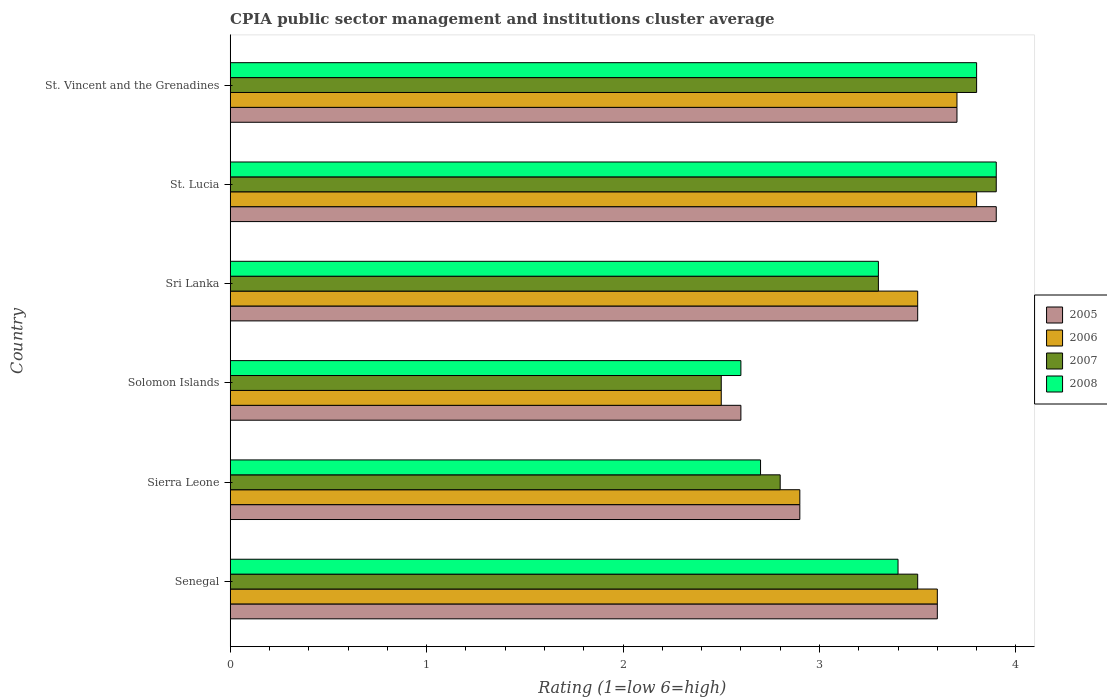How many different coloured bars are there?
Make the answer very short. 4. Are the number of bars on each tick of the Y-axis equal?
Give a very brief answer. Yes. How many bars are there on the 6th tick from the top?
Your response must be concise. 4. How many bars are there on the 2nd tick from the bottom?
Your answer should be very brief. 4. What is the label of the 2nd group of bars from the top?
Give a very brief answer. St. Lucia. Across all countries, what is the maximum CPIA rating in 2006?
Your answer should be very brief. 3.8. Across all countries, what is the minimum CPIA rating in 2005?
Provide a short and direct response. 2.6. In which country was the CPIA rating in 2005 maximum?
Your answer should be very brief. St. Lucia. In which country was the CPIA rating in 2006 minimum?
Your response must be concise. Solomon Islands. What is the total CPIA rating in 2007 in the graph?
Your answer should be compact. 19.8. What is the difference between the CPIA rating in 2006 in Senegal and that in St. Vincent and the Grenadines?
Offer a terse response. -0.1. What is the difference between the CPIA rating in 2006 in St. Lucia and the CPIA rating in 2008 in St. Vincent and the Grenadines?
Offer a very short reply. 0. What is the average CPIA rating in 2007 per country?
Provide a succinct answer. 3.3. What is the difference between the CPIA rating in 2008 and CPIA rating in 2006 in Solomon Islands?
Offer a very short reply. 0.1. What is the ratio of the CPIA rating in 2006 in Sri Lanka to that in St. Vincent and the Grenadines?
Provide a succinct answer. 0.95. Is the difference between the CPIA rating in 2008 in St. Lucia and St. Vincent and the Grenadines greater than the difference between the CPIA rating in 2006 in St. Lucia and St. Vincent and the Grenadines?
Give a very brief answer. Yes. What is the difference between the highest and the second highest CPIA rating in 2006?
Your response must be concise. 0.1. Is the sum of the CPIA rating in 2005 in Senegal and Solomon Islands greater than the maximum CPIA rating in 2008 across all countries?
Provide a short and direct response. Yes. What does the 1st bar from the top in Senegal represents?
Your answer should be compact. 2008. What does the 3rd bar from the bottom in Sierra Leone represents?
Keep it short and to the point. 2007. Are all the bars in the graph horizontal?
Offer a very short reply. Yes. How many countries are there in the graph?
Your response must be concise. 6. Are the values on the major ticks of X-axis written in scientific E-notation?
Your answer should be very brief. No. How many legend labels are there?
Your answer should be compact. 4. What is the title of the graph?
Offer a terse response. CPIA public sector management and institutions cluster average. What is the label or title of the X-axis?
Ensure brevity in your answer.  Rating (1=low 6=high). What is the label or title of the Y-axis?
Give a very brief answer. Country. What is the Rating (1=low 6=high) in 2005 in Senegal?
Keep it short and to the point. 3.6. What is the Rating (1=low 6=high) in 2008 in Senegal?
Your answer should be very brief. 3.4. What is the Rating (1=low 6=high) in 2005 in Sierra Leone?
Ensure brevity in your answer.  2.9. What is the Rating (1=low 6=high) in 2006 in Sierra Leone?
Give a very brief answer. 2.9. What is the Rating (1=low 6=high) of 2008 in Sierra Leone?
Your response must be concise. 2.7. What is the Rating (1=low 6=high) in 2008 in Solomon Islands?
Your answer should be very brief. 2.6. What is the Rating (1=low 6=high) in 2006 in Sri Lanka?
Ensure brevity in your answer.  3.5. What is the Rating (1=low 6=high) in 2007 in Sri Lanka?
Provide a short and direct response. 3.3. What is the Rating (1=low 6=high) of 2008 in Sri Lanka?
Your response must be concise. 3.3. What is the Rating (1=low 6=high) of 2005 in St. Lucia?
Give a very brief answer. 3.9. What is the Rating (1=low 6=high) in 2006 in St. Lucia?
Your answer should be very brief. 3.8. What is the Rating (1=low 6=high) of 2007 in St. Lucia?
Your response must be concise. 3.9. What is the Rating (1=low 6=high) of 2005 in St. Vincent and the Grenadines?
Provide a short and direct response. 3.7. What is the Rating (1=low 6=high) of 2007 in St. Vincent and the Grenadines?
Your answer should be very brief. 3.8. What is the Rating (1=low 6=high) of 2008 in St. Vincent and the Grenadines?
Your answer should be very brief. 3.8. Across all countries, what is the maximum Rating (1=low 6=high) of 2008?
Give a very brief answer. 3.9. Across all countries, what is the minimum Rating (1=low 6=high) in 2008?
Keep it short and to the point. 2.6. What is the total Rating (1=low 6=high) in 2005 in the graph?
Your answer should be compact. 20.2. What is the total Rating (1=low 6=high) in 2006 in the graph?
Make the answer very short. 20. What is the total Rating (1=low 6=high) of 2007 in the graph?
Offer a terse response. 19.8. What is the difference between the Rating (1=low 6=high) of 2005 in Senegal and that in Sierra Leone?
Offer a very short reply. 0.7. What is the difference between the Rating (1=low 6=high) of 2007 in Senegal and that in Sierra Leone?
Ensure brevity in your answer.  0.7. What is the difference between the Rating (1=low 6=high) in 2008 in Senegal and that in Sierra Leone?
Offer a terse response. 0.7. What is the difference between the Rating (1=low 6=high) in 2006 in Senegal and that in Solomon Islands?
Your answer should be very brief. 1.1. What is the difference between the Rating (1=low 6=high) of 2005 in Senegal and that in Sri Lanka?
Provide a short and direct response. 0.1. What is the difference between the Rating (1=low 6=high) in 2007 in Senegal and that in Sri Lanka?
Offer a very short reply. 0.2. What is the difference between the Rating (1=low 6=high) of 2006 in Senegal and that in St. Lucia?
Keep it short and to the point. -0.2. What is the difference between the Rating (1=low 6=high) of 2005 in Senegal and that in St. Vincent and the Grenadines?
Ensure brevity in your answer.  -0.1. What is the difference between the Rating (1=low 6=high) of 2006 in Senegal and that in St. Vincent and the Grenadines?
Offer a very short reply. -0.1. What is the difference between the Rating (1=low 6=high) in 2005 in Sierra Leone and that in Solomon Islands?
Provide a succinct answer. 0.3. What is the difference between the Rating (1=low 6=high) in 2006 in Sierra Leone and that in Solomon Islands?
Make the answer very short. 0.4. What is the difference between the Rating (1=low 6=high) in 2005 in Sierra Leone and that in St. Lucia?
Offer a terse response. -1. What is the difference between the Rating (1=low 6=high) of 2007 in Sierra Leone and that in St. Lucia?
Provide a succinct answer. -1.1. What is the difference between the Rating (1=low 6=high) in 2005 in Sierra Leone and that in St. Vincent and the Grenadines?
Keep it short and to the point. -0.8. What is the difference between the Rating (1=low 6=high) in 2006 in Sierra Leone and that in St. Vincent and the Grenadines?
Provide a succinct answer. -0.8. What is the difference between the Rating (1=low 6=high) of 2007 in Sierra Leone and that in St. Vincent and the Grenadines?
Make the answer very short. -1. What is the difference between the Rating (1=low 6=high) in 2008 in Sierra Leone and that in St. Vincent and the Grenadines?
Ensure brevity in your answer.  -1.1. What is the difference between the Rating (1=low 6=high) in 2005 in Solomon Islands and that in Sri Lanka?
Your answer should be very brief. -0.9. What is the difference between the Rating (1=low 6=high) in 2007 in Solomon Islands and that in Sri Lanka?
Your answer should be compact. -0.8. What is the difference between the Rating (1=low 6=high) of 2007 in Solomon Islands and that in St. Lucia?
Ensure brevity in your answer.  -1.4. What is the difference between the Rating (1=low 6=high) of 2005 in Solomon Islands and that in St. Vincent and the Grenadines?
Offer a terse response. -1.1. What is the difference between the Rating (1=low 6=high) of 2006 in Solomon Islands and that in St. Vincent and the Grenadines?
Make the answer very short. -1.2. What is the difference between the Rating (1=low 6=high) in 2005 in Sri Lanka and that in St. Lucia?
Give a very brief answer. -0.4. What is the difference between the Rating (1=low 6=high) in 2008 in Sri Lanka and that in St. Lucia?
Provide a succinct answer. -0.6. What is the difference between the Rating (1=low 6=high) of 2005 in Sri Lanka and that in St. Vincent and the Grenadines?
Provide a succinct answer. -0.2. What is the difference between the Rating (1=low 6=high) in 2008 in Sri Lanka and that in St. Vincent and the Grenadines?
Make the answer very short. -0.5. What is the difference between the Rating (1=low 6=high) of 2005 in St. Lucia and that in St. Vincent and the Grenadines?
Offer a terse response. 0.2. What is the difference between the Rating (1=low 6=high) in 2006 in St. Lucia and that in St. Vincent and the Grenadines?
Provide a short and direct response. 0.1. What is the difference between the Rating (1=low 6=high) of 2008 in St. Lucia and that in St. Vincent and the Grenadines?
Ensure brevity in your answer.  0.1. What is the difference between the Rating (1=low 6=high) of 2005 in Senegal and the Rating (1=low 6=high) of 2007 in Sierra Leone?
Your answer should be very brief. 0.8. What is the difference between the Rating (1=low 6=high) of 2005 in Senegal and the Rating (1=low 6=high) of 2008 in Sierra Leone?
Make the answer very short. 0.9. What is the difference between the Rating (1=low 6=high) of 2006 in Senegal and the Rating (1=low 6=high) of 2007 in Solomon Islands?
Provide a succinct answer. 1.1. What is the difference between the Rating (1=low 6=high) in 2007 in Senegal and the Rating (1=low 6=high) in 2008 in Solomon Islands?
Ensure brevity in your answer.  0.9. What is the difference between the Rating (1=low 6=high) in 2005 in Senegal and the Rating (1=low 6=high) in 2007 in Sri Lanka?
Offer a terse response. 0.3. What is the difference between the Rating (1=low 6=high) in 2005 in Senegal and the Rating (1=low 6=high) in 2008 in Sri Lanka?
Offer a terse response. 0.3. What is the difference between the Rating (1=low 6=high) of 2006 in Senegal and the Rating (1=low 6=high) of 2007 in Sri Lanka?
Offer a very short reply. 0.3. What is the difference between the Rating (1=low 6=high) in 2007 in Senegal and the Rating (1=low 6=high) in 2008 in Sri Lanka?
Provide a short and direct response. 0.2. What is the difference between the Rating (1=low 6=high) in 2005 in Senegal and the Rating (1=low 6=high) in 2006 in St. Lucia?
Provide a short and direct response. -0.2. What is the difference between the Rating (1=low 6=high) of 2005 in Senegal and the Rating (1=low 6=high) of 2007 in St. Lucia?
Provide a succinct answer. -0.3. What is the difference between the Rating (1=low 6=high) in 2005 in Senegal and the Rating (1=low 6=high) in 2008 in St. Lucia?
Offer a terse response. -0.3. What is the difference between the Rating (1=low 6=high) in 2006 in Senegal and the Rating (1=low 6=high) in 2007 in St. Lucia?
Offer a terse response. -0.3. What is the difference between the Rating (1=low 6=high) of 2006 in Senegal and the Rating (1=low 6=high) of 2008 in St. Lucia?
Offer a terse response. -0.3. What is the difference between the Rating (1=low 6=high) in 2007 in Senegal and the Rating (1=low 6=high) in 2008 in St. Lucia?
Your response must be concise. -0.4. What is the difference between the Rating (1=low 6=high) in 2006 in Senegal and the Rating (1=low 6=high) in 2007 in St. Vincent and the Grenadines?
Give a very brief answer. -0.2. What is the difference between the Rating (1=low 6=high) in 2006 in Senegal and the Rating (1=low 6=high) in 2008 in St. Vincent and the Grenadines?
Give a very brief answer. -0.2. What is the difference between the Rating (1=low 6=high) of 2005 in Sierra Leone and the Rating (1=low 6=high) of 2007 in Solomon Islands?
Provide a succinct answer. 0.4. What is the difference between the Rating (1=low 6=high) in 2006 in Sierra Leone and the Rating (1=low 6=high) in 2007 in Solomon Islands?
Ensure brevity in your answer.  0.4. What is the difference between the Rating (1=low 6=high) of 2006 in Sierra Leone and the Rating (1=low 6=high) of 2008 in Solomon Islands?
Keep it short and to the point. 0.3. What is the difference between the Rating (1=low 6=high) in 2005 in Sierra Leone and the Rating (1=low 6=high) in 2006 in Sri Lanka?
Give a very brief answer. -0.6. What is the difference between the Rating (1=low 6=high) of 2005 in Sierra Leone and the Rating (1=low 6=high) of 2008 in Sri Lanka?
Your response must be concise. -0.4. What is the difference between the Rating (1=low 6=high) in 2006 in Sierra Leone and the Rating (1=low 6=high) in 2007 in Sri Lanka?
Provide a succinct answer. -0.4. What is the difference between the Rating (1=low 6=high) of 2006 in Sierra Leone and the Rating (1=low 6=high) of 2008 in Sri Lanka?
Your answer should be very brief. -0.4. What is the difference between the Rating (1=low 6=high) in 2005 in Sierra Leone and the Rating (1=low 6=high) in 2007 in St. Lucia?
Ensure brevity in your answer.  -1. What is the difference between the Rating (1=low 6=high) in 2005 in Sierra Leone and the Rating (1=low 6=high) in 2006 in St. Vincent and the Grenadines?
Provide a succinct answer. -0.8. What is the difference between the Rating (1=low 6=high) of 2006 in Sierra Leone and the Rating (1=low 6=high) of 2007 in St. Vincent and the Grenadines?
Provide a short and direct response. -0.9. What is the difference between the Rating (1=low 6=high) of 2006 in Sierra Leone and the Rating (1=low 6=high) of 2008 in St. Vincent and the Grenadines?
Your response must be concise. -0.9. What is the difference between the Rating (1=low 6=high) in 2007 in Sierra Leone and the Rating (1=low 6=high) in 2008 in St. Vincent and the Grenadines?
Provide a short and direct response. -1. What is the difference between the Rating (1=low 6=high) in 2006 in Solomon Islands and the Rating (1=low 6=high) in 2007 in Sri Lanka?
Your response must be concise. -0.8. What is the difference between the Rating (1=low 6=high) in 2006 in Solomon Islands and the Rating (1=low 6=high) in 2008 in Sri Lanka?
Offer a terse response. -0.8. What is the difference between the Rating (1=low 6=high) in 2007 in Solomon Islands and the Rating (1=low 6=high) in 2008 in Sri Lanka?
Your answer should be compact. -0.8. What is the difference between the Rating (1=low 6=high) of 2007 in Solomon Islands and the Rating (1=low 6=high) of 2008 in St. Lucia?
Offer a very short reply. -1.4. What is the difference between the Rating (1=low 6=high) of 2005 in Solomon Islands and the Rating (1=low 6=high) of 2006 in St. Vincent and the Grenadines?
Keep it short and to the point. -1.1. What is the difference between the Rating (1=low 6=high) of 2005 in Solomon Islands and the Rating (1=low 6=high) of 2007 in St. Vincent and the Grenadines?
Ensure brevity in your answer.  -1.2. What is the difference between the Rating (1=low 6=high) of 2006 in Solomon Islands and the Rating (1=low 6=high) of 2007 in St. Vincent and the Grenadines?
Your response must be concise. -1.3. What is the difference between the Rating (1=low 6=high) in 2005 in Sri Lanka and the Rating (1=low 6=high) in 2008 in St. Lucia?
Your response must be concise. -0.4. What is the difference between the Rating (1=low 6=high) in 2006 in Sri Lanka and the Rating (1=low 6=high) in 2007 in St. Lucia?
Make the answer very short. -0.4. What is the difference between the Rating (1=low 6=high) in 2006 in Sri Lanka and the Rating (1=low 6=high) in 2008 in St. Lucia?
Offer a very short reply. -0.4. What is the difference between the Rating (1=low 6=high) in 2007 in Sri Lanka and the Rating (1=low 6=high) in 2008 in St. Lucia?
Keep it short and to the point. -0.6. What is the difference between the Rating (1=low 6=high) in 2005 in Sri Lanka and the Rating (1=low 6=high) in 2007 in St. Vincent and the Grenadines?
Offer a terse response. -0.3. What is the difference between the Rating (1=low 6=high) in 2005 in Sri Lanka and the Rating (1=low 6=high) in 2008 in St. Vincent and the Grenadines?
Give a very brief answer. -0.3. What is the difference between the Rating (1=low 6=high) in 2006 in Sri Lanka and the Rating (1=low 6=high) in 2008 in St. Vincent and the Grenadines?
Ensure brevity in your answer.  -0.3. What is the difference between the Rating (1=low 6=high) in 2007 in Sri Lanka and the Rating (1=low 6=high) in 2008 in St. Vincent and the Grenadines?
Provide a short and direct response. -0.5. What is the difference between the Rating (1=low 6=high) in 2005 in St. Lucia and the Rating (1=low 6=high) in 2007 in St. Vincent and the Grenadines?
Provide a succinct answer. 0.1. What is the average Rating (1=low 6=high) in 2005 per country?
Keep it short and to the point. 3.37. What is the average Rating (1=low 6=high) in 2007 per country?
Your response must be concise. 3.3. What is the average Rating (1=low 6=high) in 2008 per country?
Give a very brief answer. 3.28. What is the difference between the Rating (1=low 6=high) in 2005 and Rating (1=low 6=high) in 2007 in Senegal?
Provide a short and direct response. 0.1. What is the difference between the Rating (1=low 6=high) in 2006 and Rating (1=low 6=high) in 2007 in Senegal?
Offer a very short reply. 0.1. What is the difference between the Rating (1=low 6=high) of 2006 and Rating (1=low 6=high) of 2008 in Sierra Leone?
Keep it short and to the point. 0.2. What is the difference between the Rating (1=low 6=high) in 2006 and Rating (1=low 6=high) in 2007 in Solomon Islands?
Provide a short and direct response. 0. What is the difference between the Rating (1=low 6=high) of 2006 and Rating (1=low 6=high) of 2008 in Solomon Islands?
Provide a short and direct response. -0.1. What is the difference between the Rating (1=low 6=high) in 2006 and Rating (1=low 6=high) in 2008 in Sri Lanka?
Your answer should be very brief. 0.2. What is the difference between the Rating (1=low 6=high) in 2005 and Rating (1=low 6=high) in 2007 in St. Lucia?
Your response must be concise. 0. What is the difference between the Rating (1=low 6=high) of 2006 and Rating (1=low 6=high) of 2007 in St. Lucia?
Offer a terse response. -0.1. What is the difference between the Rating (1=low 6=high) of 2007 and Rating (1=low 6=high) of 2008 in St. Lucia?
Your answer should be compact. 0. What is the difference between the Rating (1=low 6=high) of 2007 and Rating (1=low 6=high) of 2008 in St. Vincent and the Grenadines?
Offer a very short reply. 0. What is the ratio of the Rating (1=low 6=high) of 2005 in Senegal to that in Sierra Leone?
Offer a terse response. 1.24. What is the ratio of the Rating (1=low 6=high) in 2006 in Senegal to that in Sierra Leone?
Your response must be concise. 1.24. What is the ratio of the Rating (1=low 6=high) in 2007 in Senegal to that in Sierra Leone?
Your answer should be very brief. 1.25. What is the ratio of the Rating (1=low 6=high) of 2008 in Senegal to that in Sierra Leone?
Your response must be concise. 1.26. What is the ratio of the Rating (1=low 6=high) of 2005 in Senegal to that in Solomon Islands?
Offer a very short reply. 1.38. What is the ratio of the Rating (1=low 6=high) in 2006 in Senegal to that in Solomon Islands?
Your response must be concise. 1.44. What is the ratio of the Rating (1=low 6=high) of 2008 in Senegal to that in Solomon Islands?
Offer a very short reply. 1.31. What is the ratio of the Rating (1=low 6=high) in 2005 in Senegal to that in Sri Lanka?
Provide a short and direct response. 1.03. What is the ratio of the Rating (1=low 6=high) of 2006 in Senegal to that in Sri Lanka?
Make the answer very short. 1.03. What is the ratio of the Rating (1=low 6=high) in 2007 in Senegal to that in Sri Lanka?
Give a very brief answer. 1.06. What is the ratio of the Rating (1=low 6=high) of 2008 in Senegal to that in Sri Lanka?
Your response must be concise. 1.03. What is the ratio of the Rating (1=low 6=high) of 2007 in Senegal to that in St. Lucia?
Make the answer very short. 0.9. What is the ratio of the Rating (1=low 6=high) in 2008 in Senegal to that in St. Lucia?
Keep it short and to the point. 0.87. What is the ratio of the Rating (1=low 6=high) of 2005 in Senegal to that in St. Vincent and the Grenadines?
Your answer should be compact. 0.97. What is the ratio of the Rating (1=low 6=high) in 2007 in Senegal to that in St. Vincent and the Grenadines?
Make the answer very short. 0.92. What is the ratio of the Rating (1=low 6=high) in 2008 in Senegal to that in St. Vincent and the Grenadines?
Offer a very short reply. 0.89. What is the ratio of the Rating (1=low 6=high) of 2005 in Sierra Leone to that in Solomon Islands?
Your response must be concise. 1.12. What is the ratio of the Rating (1=low 6=high) of 2006 in Sierra Leone to that in Solomon Islands?
Your answer should be very brief. 1.16. What is the ratio of the Rating (1=low 6=high) in 2007 in Sierra Leone to that in Solomon Islands?
Make the answer very short. 1.12. What is the ratio of the Rating (1=low 6=high) in 2005 in Sierra Leone to that in Sri Lanka?
Your answer should be compact. 0.83. What is the ratio of the Rating (1=low 6=high) of 2006 in Sierra Leone to that in Sri Lanka?
Provide a succinct answer. 0.83. What is the ratio of the Rating (1=low 6=high) in 2007 in Sierra Leone to that in Sri Lanka?
Your answer should be very brief. 0.85. What is the ratio of the Rating (1=low 6=high) of 2008 in Sierra Leone to that in Sri Lanka?
Offer a very short reply. 0.82. What is the ratio of the Rating (1=low 6=high) of 2005 in Sierra Leone to that in St. Lucia?
Offer a terse response. 0.74. What is the ratio of the Rating (1=low 6=high) in 2006 in Sierra Leone to that in St. Lucia?
Ensure brevity in your answer.  0.76. What is the ratio of the Rating (1=low 6=high) in 2007 in Sierra Leone to that in St. Lucia?
Give a very brief answer. 0.72. What is the ratio of the Rating (1=low 6=high) of 2008 in Sierra Leone to that in St. Lucia?
Your response must be concise. 0.69. What is the ratio of the Rating (1=low 6=high) of 2005 in Sierra Leone to that in St. Vincent and the Grenadines?
Offer a terse response. 0.78. What is the ratio of the Rating (1=low 6=high) of 2006 in Sierra Leone to that in St. Vincent and the Grenadines?
Ensure brevity in your answer.  0.78. What is the ratio of the Rating (1=low 6=high) of 2007 in Sierra Leone to that in St. Vincent and the Grenadines?
Your answer should be very brief. 0.74. What is the ratio of the Rating (1=low 6=high) in 2008 in Sierra Leone to that in St. Vincent and the Grenadines?
Your answer should be very brief. 0.71. What is the ratio of the Rating (1=low 6=high) of 2005 in Solomon Islands to that in Sri Lanka?
Offer a very short reply. 0.74. What is the ratio of the Rating (1=low 6=high) in 2006 in Solomon Islands to that in Sri Lanka?
Ensure brevity in your answer.  0.71. What is the ratio of the Rating (1=low 6=high) in 2007 in Solomon Islands to that in Sri Lanka?
Your answer should be compact. 0.76. What is the ratio of the Rating (1=low 6=high) of 2008 in Solomon Islands to that in Sri Lanka?
Offer a very short reply. 0.79. What is the ratio of the Rating (1=low 6=high) of 2006 in Solomon Islands to that in St. Lucia?
Make the answer very short. 0.66. What is the ratio of the Rating (1=low 6=high) in 2007 in Solomon Islands to that in St. Lucia?
Provide a short and direct response. 0.64. What is the ratio of the Rating (1=low 6=high) of 2008 in Solomon Islands to that in St. Lucia?
Make the answer very short. 0.67. What is the ratio of the Rating (1=low 6=high) of 2005 in Solomon Islands to that in St. Vincent and the Grenadines?
Provide a short and direct response. 0.7. What is the ratio of the Rating (1=low 6=high) in 2006 in Solomon Islands to that in St. Vincent and the Grenadines?
Make the answer very short. 0.68. What is the ratio of the Rating (1=low 6=high) in 2007 in Solomon Islands to that in St. Vincent and the Grenadines?
Ensure brevity in your answer.  0.66. What is the ratio of the Rating (1=low 6=high) of 2008 in Solomon Islands to that in St. Vincent and the Grenadines?
Keep it short and to the point. 0.68. What is the ratio of the Rating (1=low 6=high) of 2005 in Sri Lanka to that in St. Lucia?
Provide a short and direct response. 0.9. What is the ratio of the Rating (1=low 6=high) in 2006 in Sri Lanka to that in St. Lucia?
Offer a terse response. 0.92. What is the ratio of the Rating (1=low 6=high) of 2007 in Sri Lanka to that in St. Lucia?
Keep it short and to the point. 0.85. What is the ratio of the Rating (1=low 6=high) of 2008 in Sri Lanka to that in St. Lucia?
Offer a terse response. 0.85. What is the ratio of the Rating (1=low 6=high) of 2005 in Sri Lanka to that in St. Vincent and the Grenadines?
Your answer should be compact. 0.95. What is the ratio of the Rating (1=low 6=high) in 2006 in Sri Lanka to that in St. Vincent and the Grenadines?
Your answer should be very brief. 0.95. What is the ratio of the Rating (1=low 6=high) in 2007 in Sri Lanka to that in St. Vincent and the Grenadines?
Make the answer very short. 0.87. What is the ratio of the Rating (1=low 6=high) of 2008 in Sri Lanka to that in St. Vincent and the Grenadines?
Provide a short and direct response. 0.87. What is the ratio of the Rating (1=low 6=high) in 2005 in St. Lucia to that in St. Vincent and the Grenadines?
Provide a short and direct response. 1.05. What is the ratio of the Rating (1=low 6=high) of 2007 in St. Lucia to that in St. Vincent and the Grenadines?
Provide a short and direct response. 1.03. What is the ratio of the Rating (1=low 6=high) of 2008 in St. Lucia to that in St. Vincent and the Grenadines?
Offer a terse response. 1.03. What is the difference between the highest and the second highest Rating (1=low 6=high) in 2007?
Offer a terse response. 0.1. What is the difference between the highest and the second highest Rating (1=low 6=high) of 2008?
Provide a succinct answer. 0.1. What is the difference between the highest and the lowest Rating (1=low 6=high) of 2005?
Offer a very short reply. 1.3. What is the difference between the highest and the lowest Rating (1=low 6=high) of 2006?
Provide a succinct answer. 1.3. What is the difference between the highest and the lowest Rating (1=low 6=high) of 2007?
Make the answer very short. 1.4. What is the difference between the highest and the lowest Rating (1=low 6=high) of 2008?
Give a very brief answer. 1.3. 